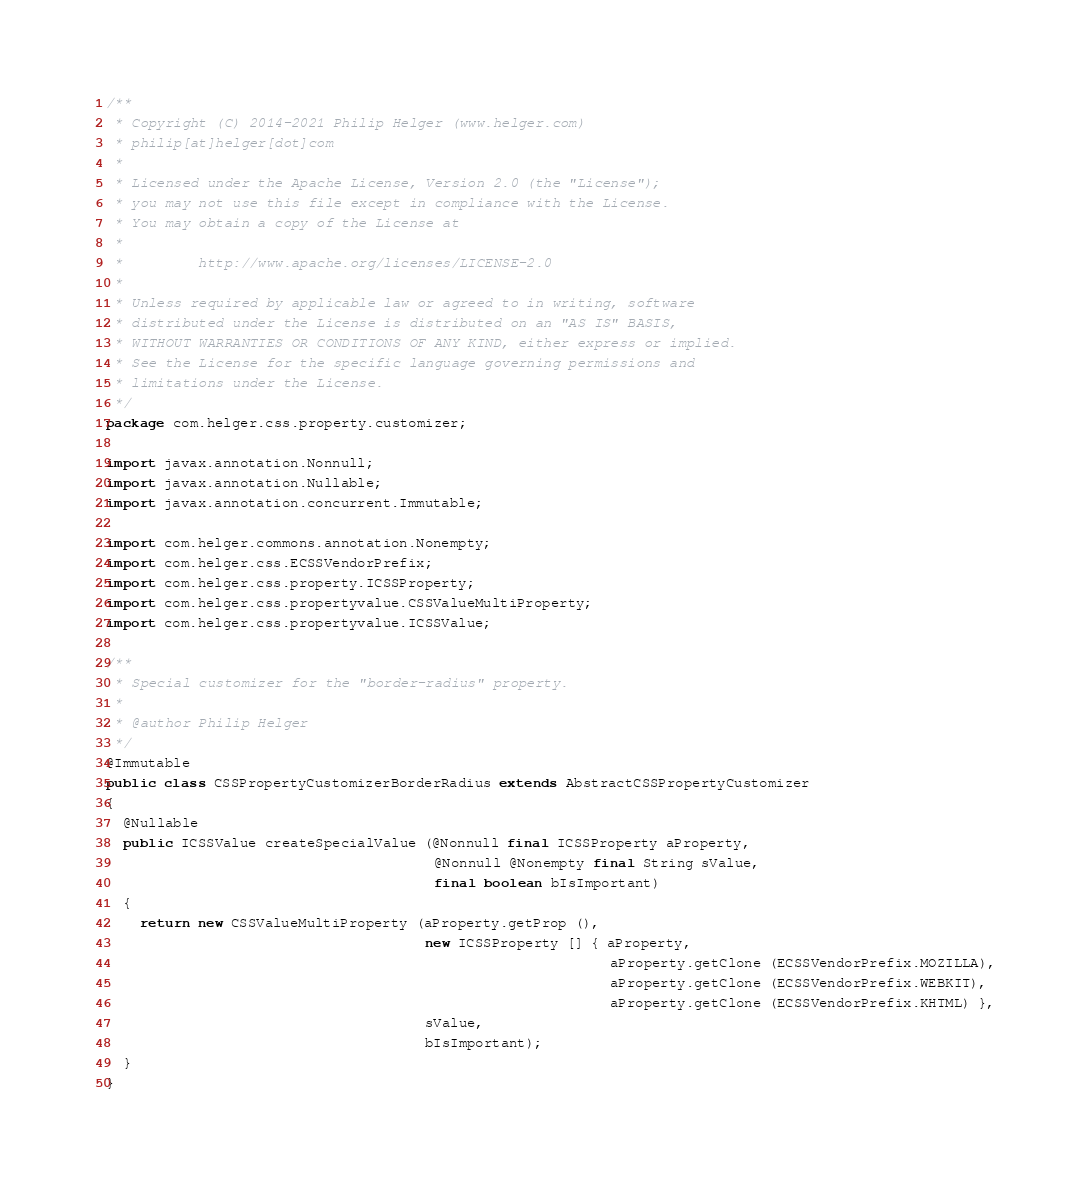<code> <loc_0><loc_0><loc_500><loc_500><_Java_>/**
 * Copyright (C) 2014-2021 Philip Helger (www.helger.com)
 * philip[at]helger[dot]com
 *
 * Licensed under the Apache License, Version 2.0 (the "License");
 * you may not use this file except in compliance with the License.
 * You may obtain a copy of the License at
 *
 *         http://www.apache.org/licenses/LICENSE-2.0
 *
 * Unless required by applicable law or agreed to in writing, software
 * distributed under the License is distributed on an "AS IS" BASIS,
 * WITHOUT WARRANTIES OR CONDITIONS OF ANY KIND, either express or implied.
 * See the License for the specific language governing permissions and
 * limitations under the License.
 */
package com.helger.css.property.customizer;

import javax.annotation.Nonnull;
import javax.annotation.Nullable;
import javax.annotation.concurrent.Immutable;

import com.helger.commons.annotation.Nonempty;
import com.helger.css.ECSSVendorPrefix;
import com.helger.css.property.ICSSProperty;
import com.helger.css.propertyvalue.CSSValueMultiProperty;
import com.helger.css.propertyvalue.ICSSValue;

/**
 * Special customizer for the "border-radius" property.
 *
 * @author Philip Helger
 */
@Immutable
public class CSSPropertyCustomizerBorderRadius extends AbstractCSSPropertyCustomizer
{
  @Nullable
  public ICSSValue createSpecialValue (@Nonnull final ICSSProperty aProperty,
                                       @Nonnull @Nonempty final String sValue,
                                       final boolean bIsImportant)
  {
    return new CSSValueMultiProperty (aProperty.getProp (),
                                      new ICSSProperty [] { aProperty,
                                                            aProperty.getClone (ECSSVendorPrefix.MOZILLA),
                                                            aProperty.getClone (ECSSVendorPrefix.WEBKIT),
                                                            aProperty.getClone (ECSSVendorPrefix.KHTML) },
                                      sValue,
                                      bIsImportant);
  }
}
</code> 